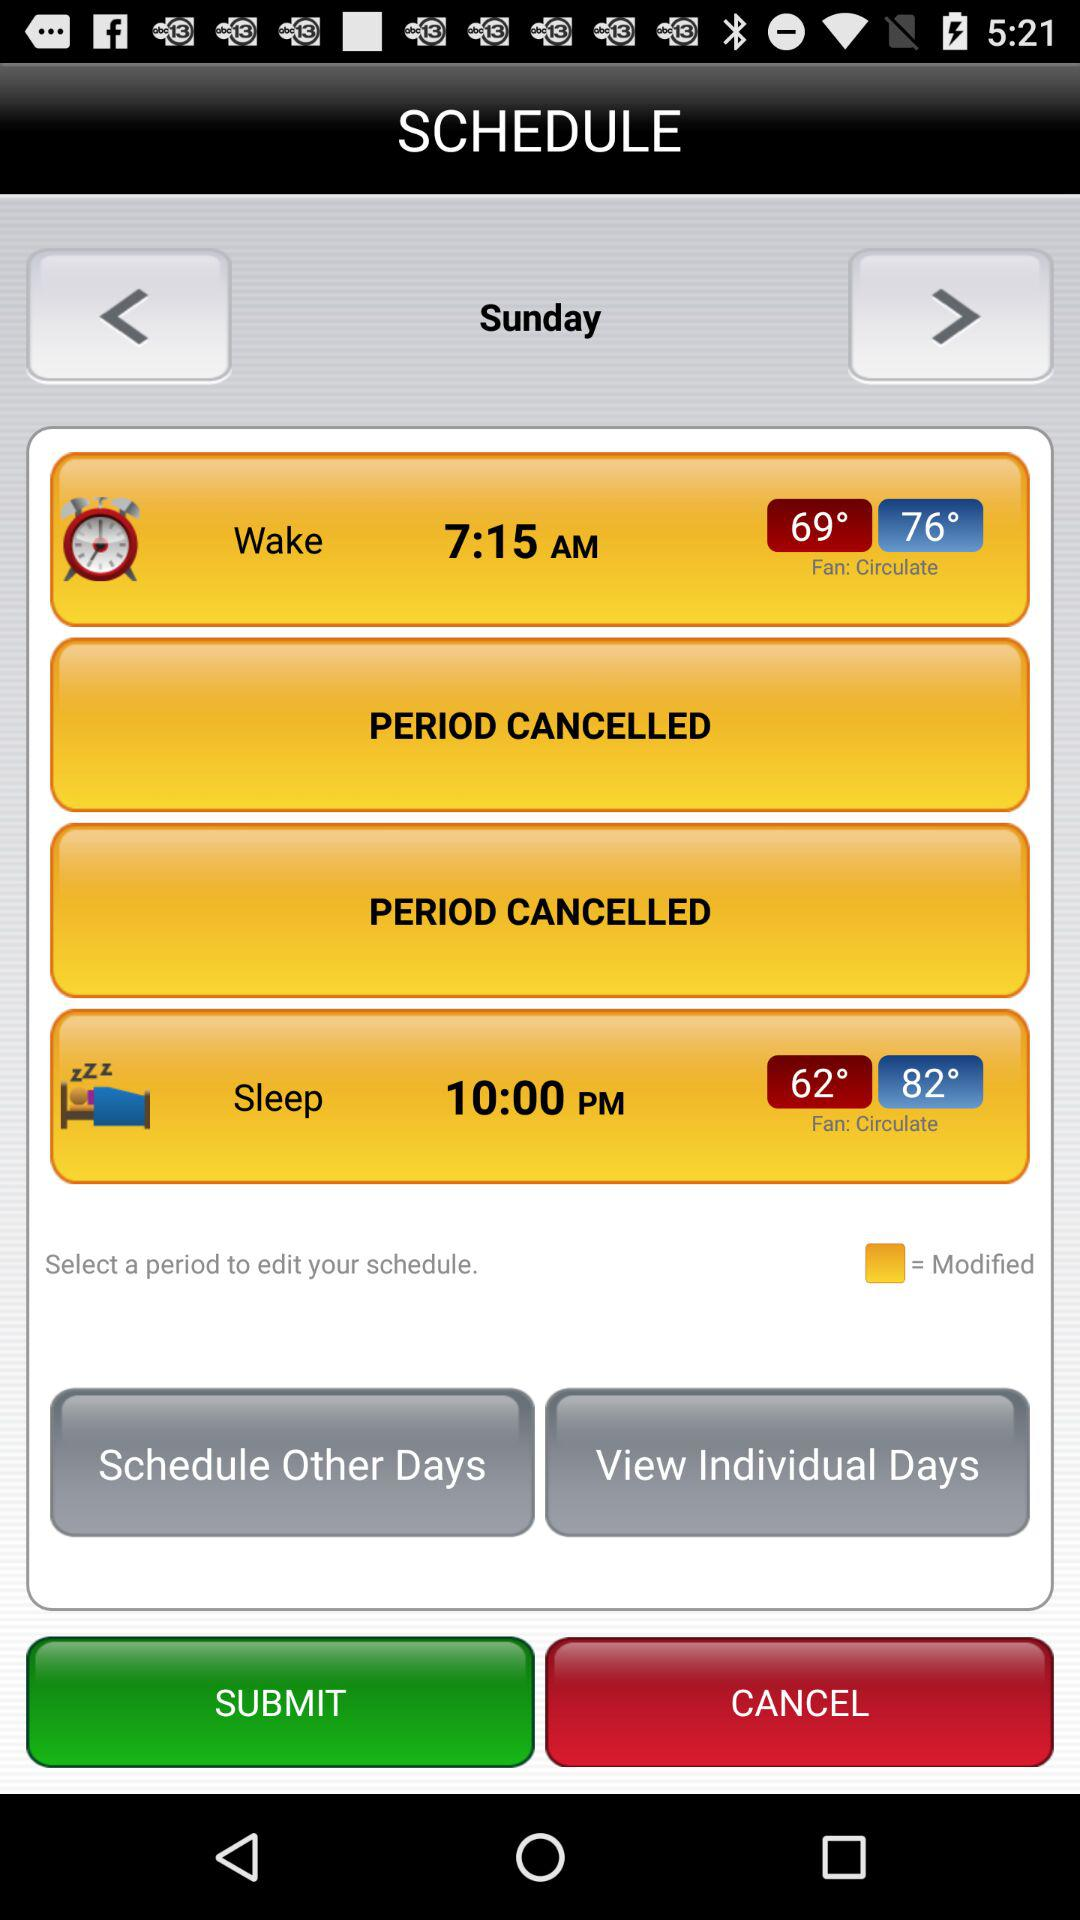What is the fan circulation at 7:15 am?
When the provided information is insufficient, respond with <no answer>. <no answer> 